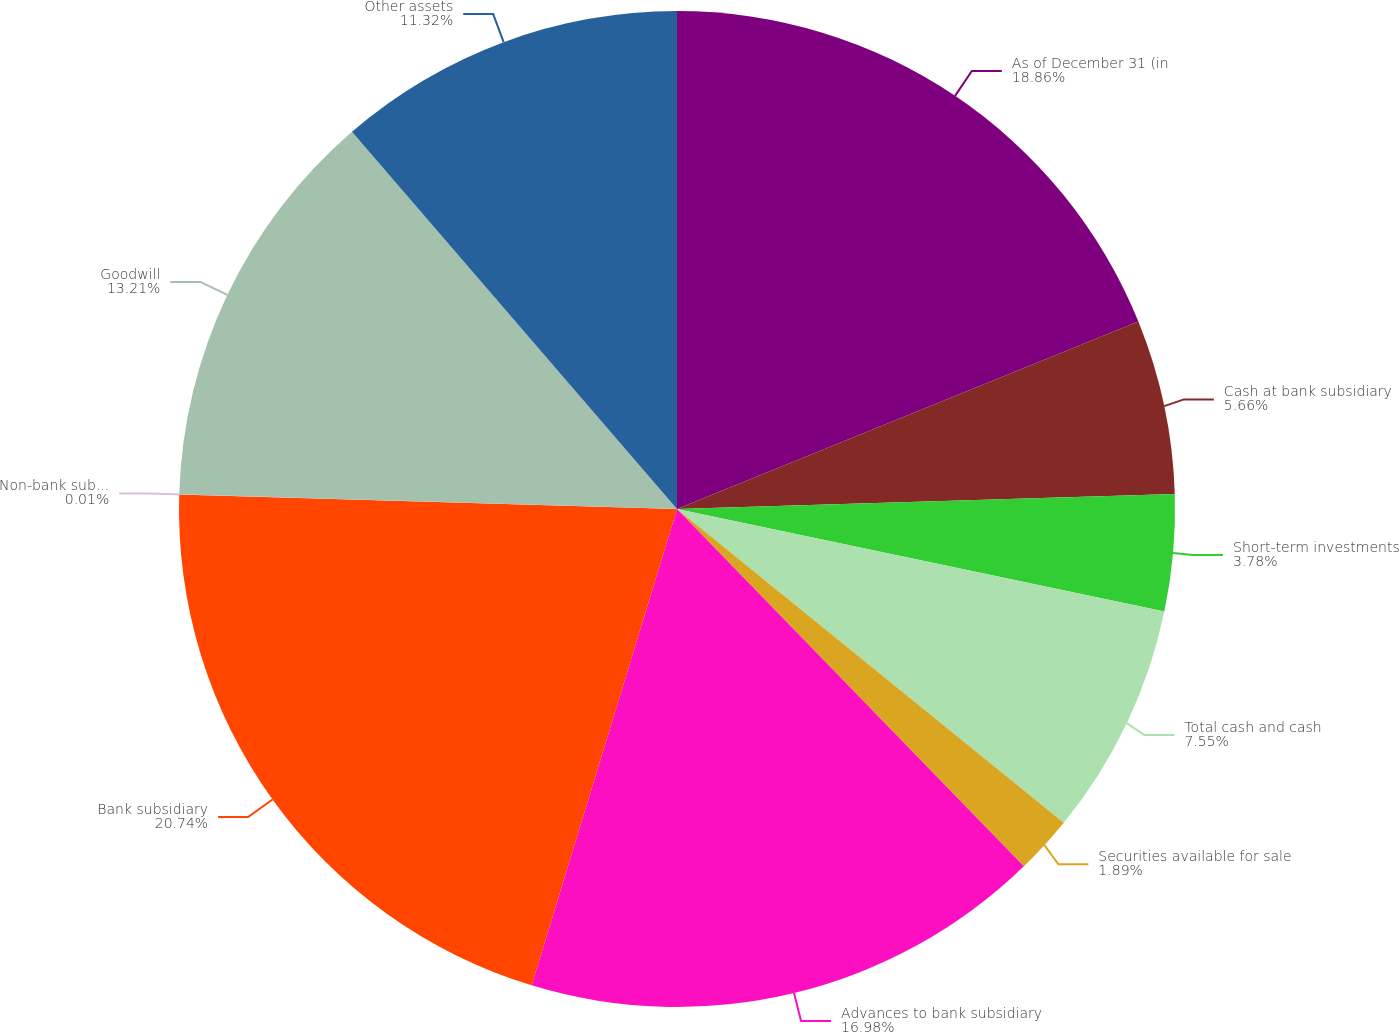Convert chart to OTSL. <chart><loc_0><loc_0><loc_500><loc_500><pie_chart><fcel>As of December 31 (in<fcel>Cash at bank subsidiary<fcel>Short-term investments<fcel>Total cash and cash<fcel>Securities available for sale<fcel>Advances to bank subsidiary<fcel>Bank subsidiary<fcel>Non-bank subsidiaries<fcel>Goodwill<fcel>Other assets<nl><fcel>18.86%<fcel>5.66%<fcel>3.78%<fcel>7.55%<fcel>1.89%<fcel>16.98%<fcel>20.75%<fcel>0.01%<fcel>13.21%<fcel>11.32%<nl></chart> 